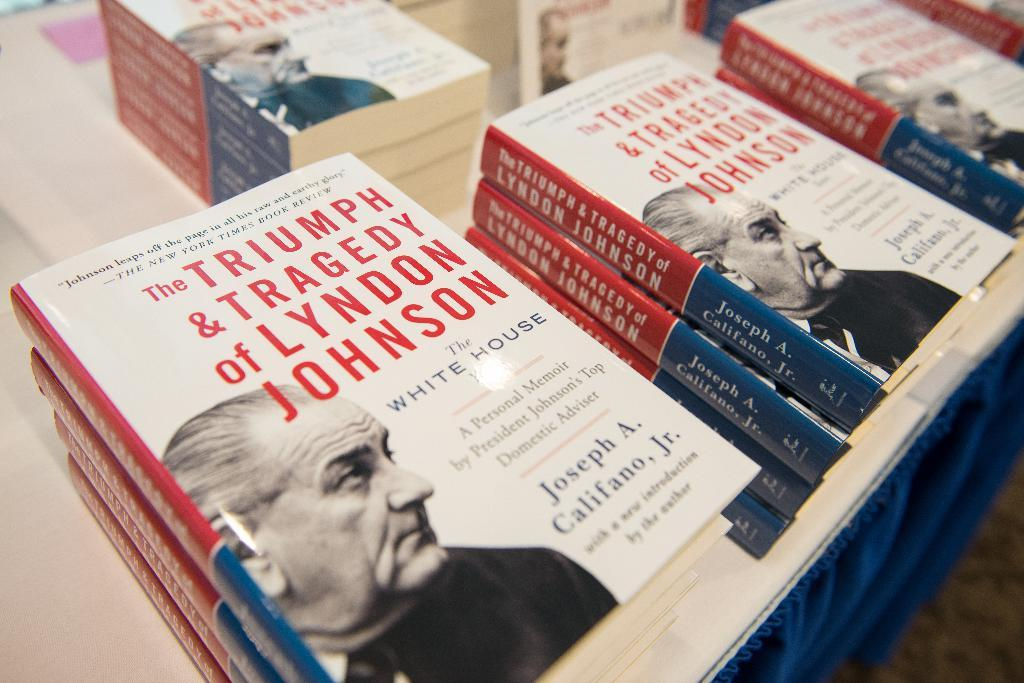<image>
Summarize the visual content of the image. The triumph and tragedy of Lyndon Johnson by Joseph A. Califano, Jr. 